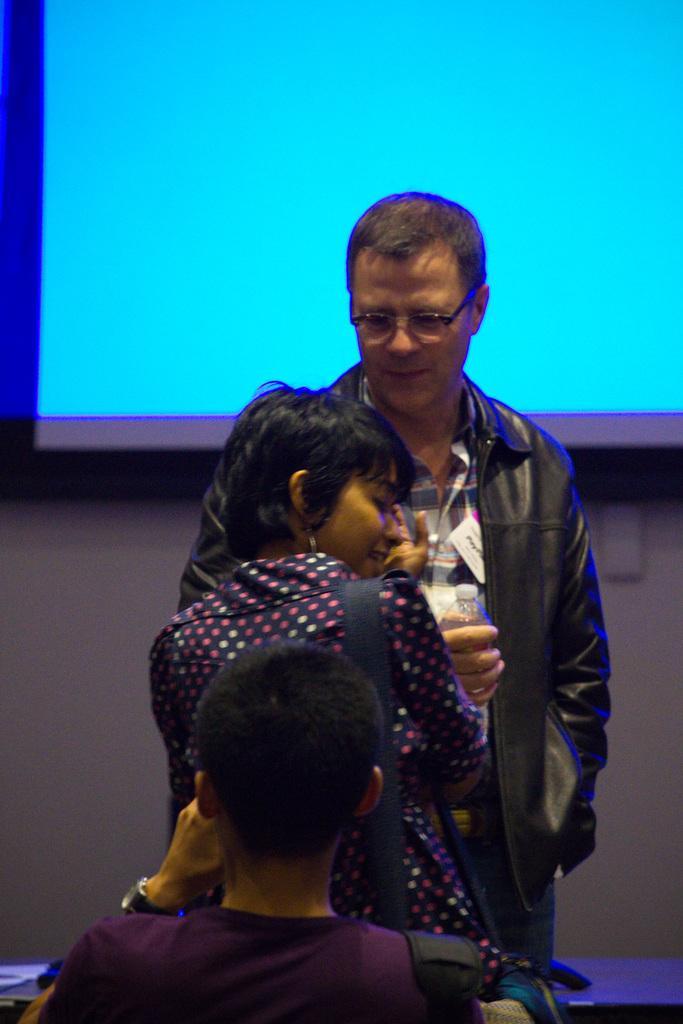How would you summarize this image in a sentence or two? In this image we can see a man holding the water bottle and standing. We can also see a woman wearing the bag. There is also another person. In the background we can see the wall and also the display screen. 